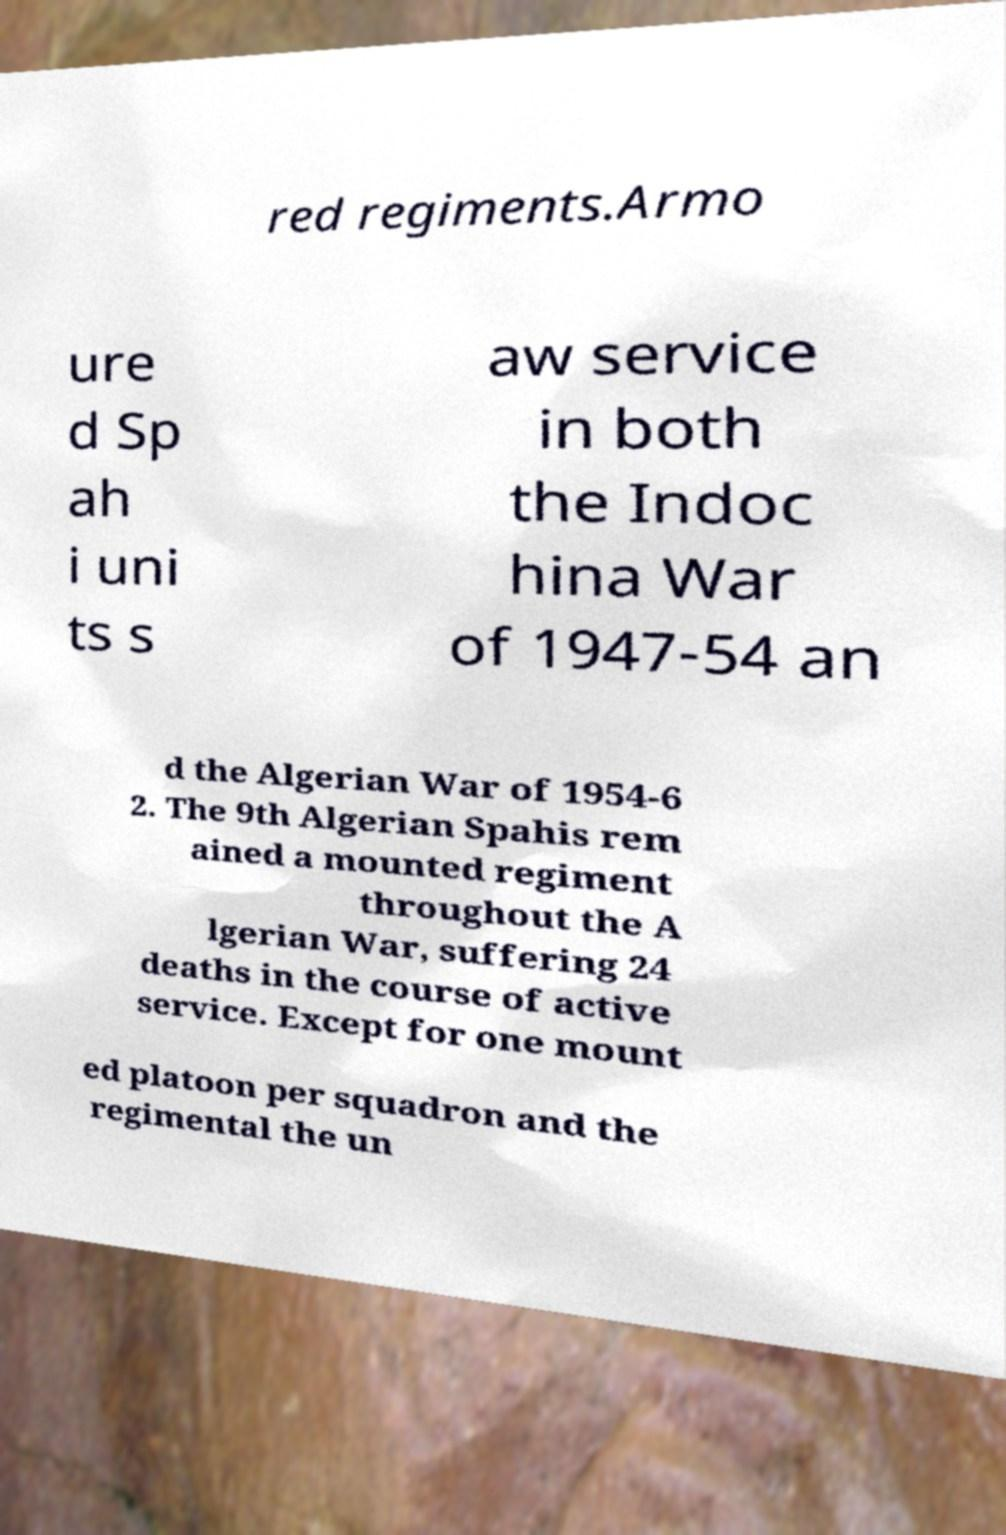Can you read and provide the text displayed in the image?This photo seems to have some interesting text. Can you extract and type it out for me? red regiments.Armo ure d Sp ah i uni ts s aw service in both the Indoc hina War of 1947-54 an d the Algerian War of 1954-6 2. The 9th Algerian Spahis rem ained a mounted regiment throughout the A lgerian War, suffering 24 deaths in the course of active service. Except for one mount ed platoon per squadron and the regimental the un 